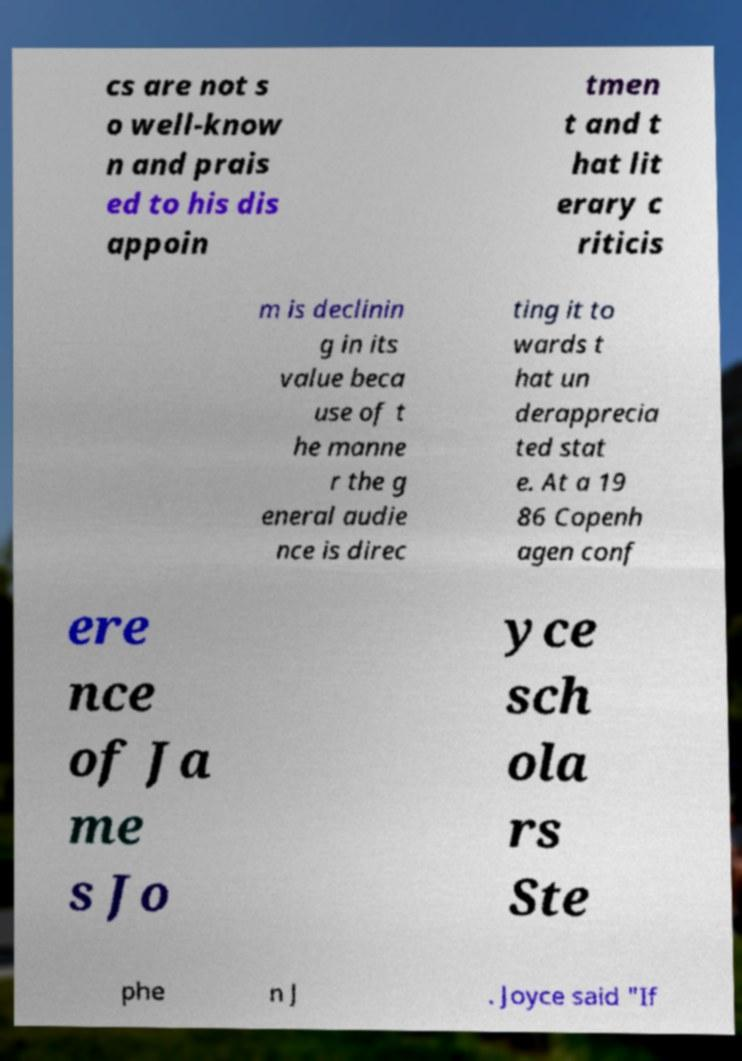I need the written content from this picture converted into text. Can you do that? cs are not s o well-know n and prais ed to his dis appoin tmen t and t hat lit erary c riticis m is declinin g in its value beca use of t he manne r the g eneral audie nce is direc ting it to wards t hat un derapprecia ted stat e. At a 19 86 Copenh agen conf ere nce of Ja me s Jo yce sch ola rs Ste phe n J . Joyce said "If 